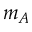Convert formula to latex. <formula><loc_0><loc_0><loc_500><loc_500>m _ { A }</formula> 